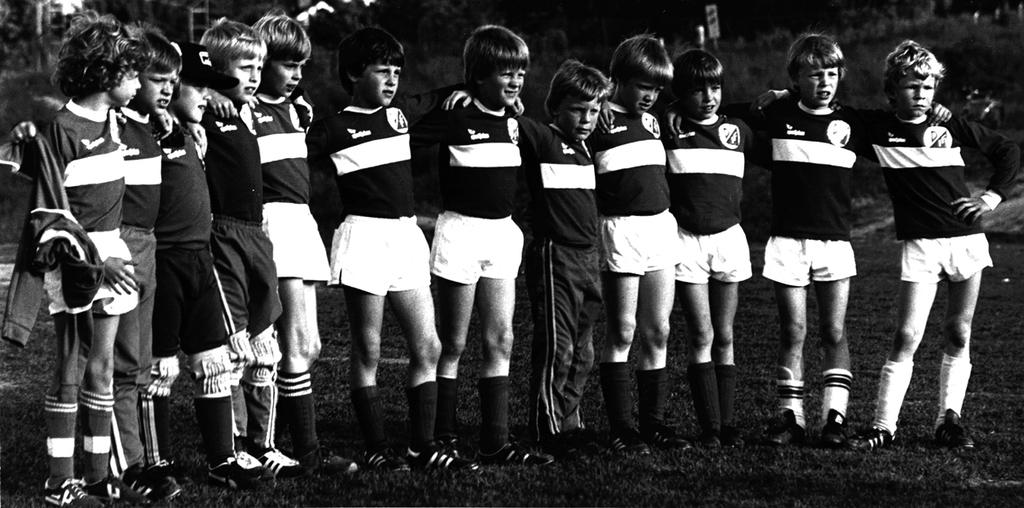How many people are in the image? There is a group of people in the image. What is the surface the people are standing on? The people are standing on the grass. What can be seen in the background of the image? There are trees visible in the background. What is the color scheme of the image? The image is in black and white. What is the price of the cows in the image? There are no cows present in the image. How does the memory of the people in the image affect their behavior? The image does not provide information about the people's memories or how they might affect their behavior. 